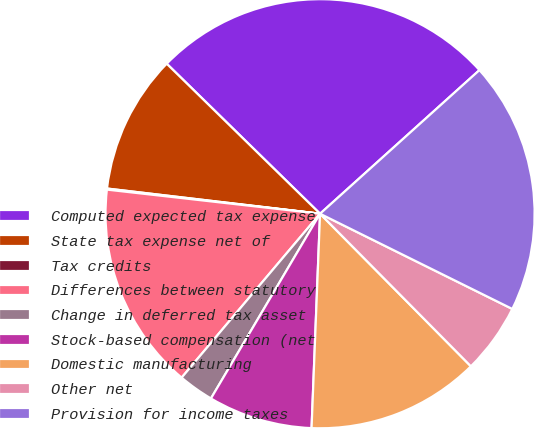<chart> <loc_0><loc_0><loc_500><loc_500><pie_chart><fcel>Computed expected tax expense<fcel>State tax expense net of<fcel>Tax credits<fcel>Differences between statutory<fcel>Change in deferred tax asset<fcel>Stock-based compensation (net<fcel>Domestic manufacturing<fcel>Other net<fcel>Provision for income taxes<nl><fcel>26.0%<fcel>10.45%<fcel>0.08%<fcel>15.63%<fcel>2.67%<fcel>7.86%<fcel>13.04%<fcel>5.27%<fcel>18.99%<nl></chart> 